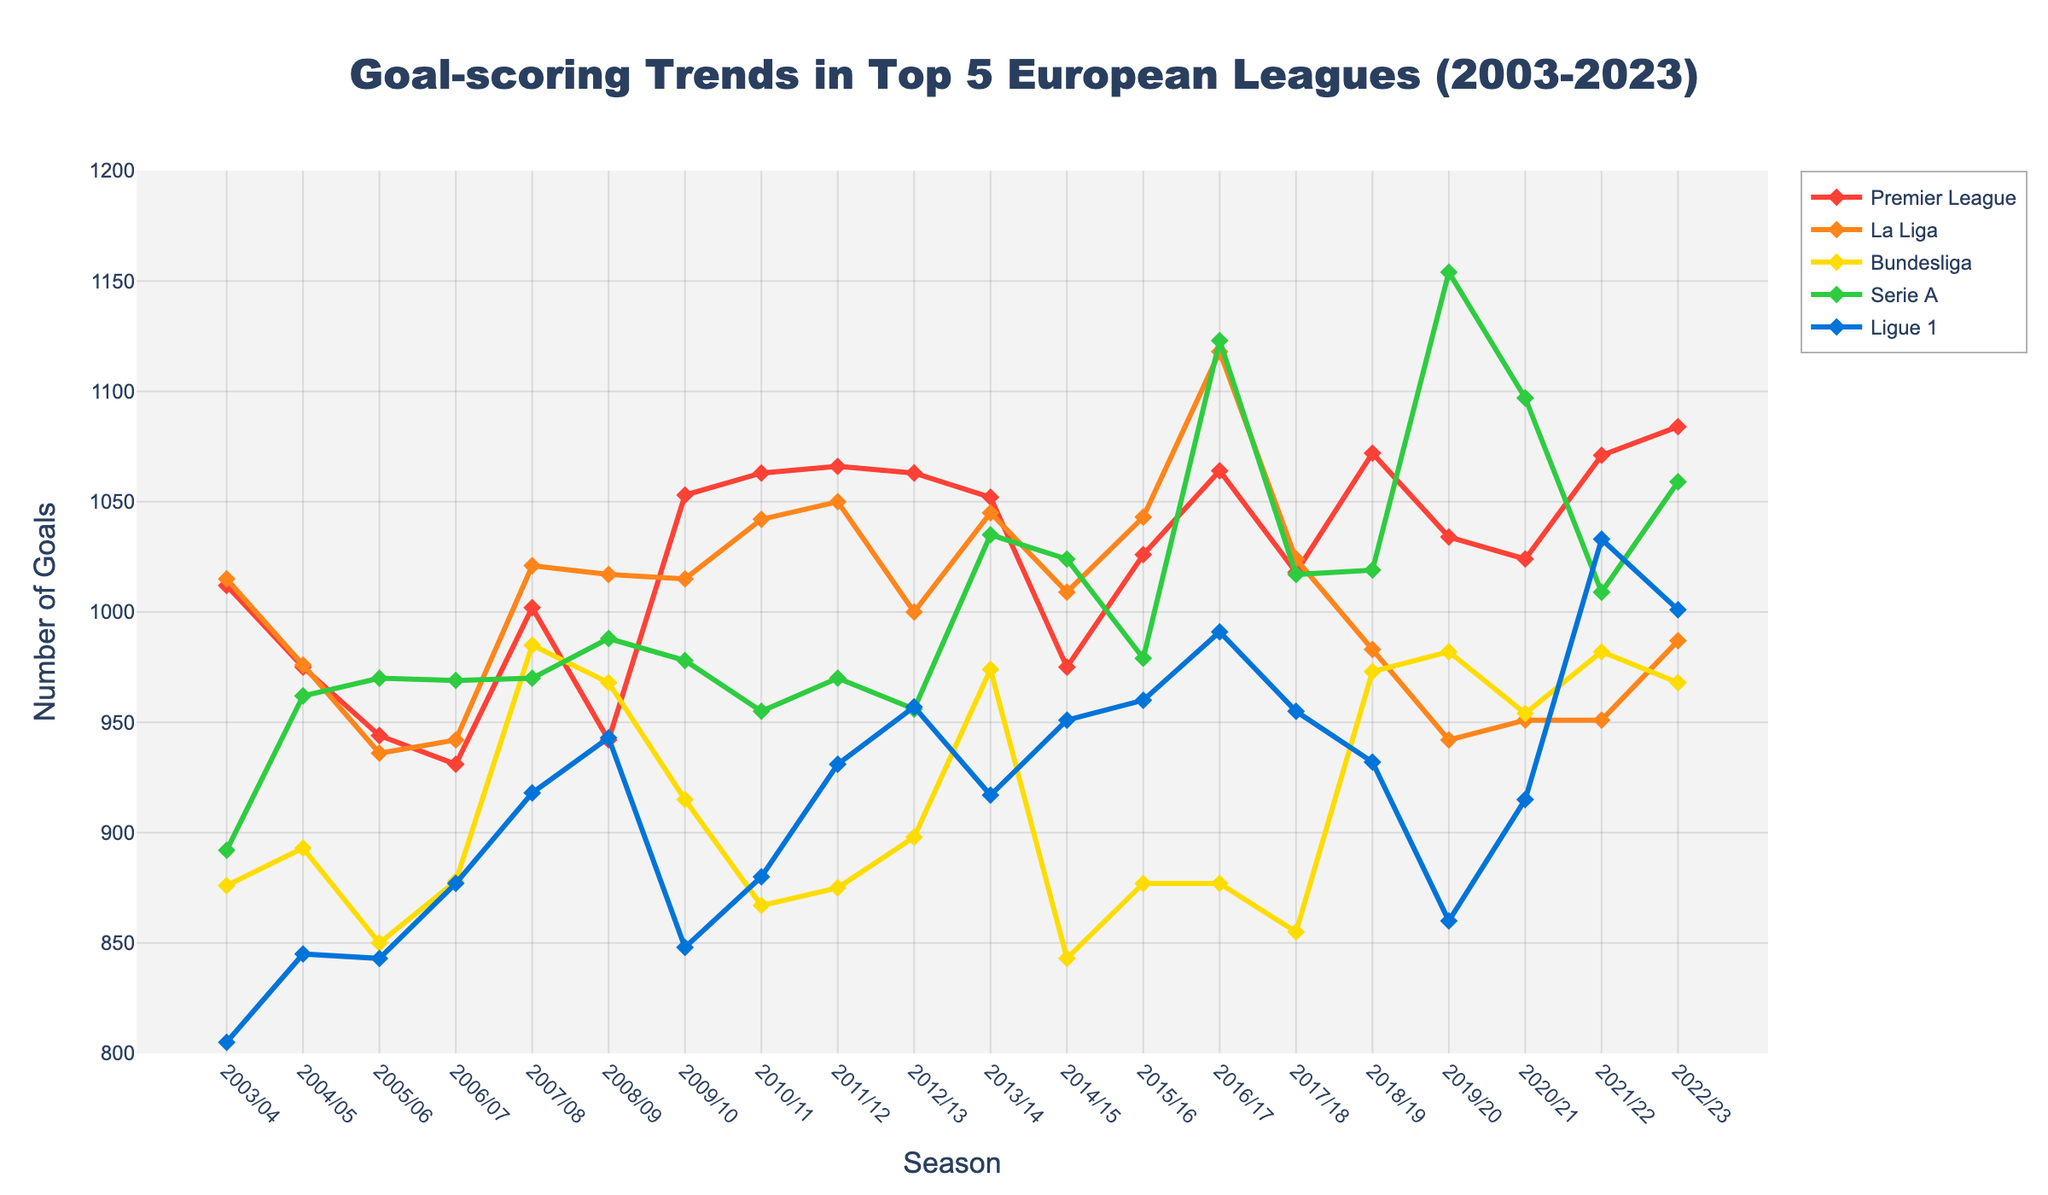Which league scored the most goals in the 2016/17 season? Looking at the 2016/17 season data, Serie A topped the chart with the highest number of goals scored.
Answer: Serie A In which season did the Bundesliga have its lowest goal tally? By examining the line for the Bundesliga, the lowest point occurs in the 2014/15 season.
Answer: 2014/15 Over the 20 seasons, did the Premier League ever score fewer goals than La Liga? By comparing the lines, we see that in the seasons 2004/05 and 2006/07, the Premier League scored fewer goals than La Liga.
Answer: Yes What's the average number of goals scored by Ligue 1 during the seasons 2003/04 to 2022/23? Sum up all the goals scored by Ligue 1 over the seasons and divide by the number of seasons (20). (805+845+843+877+918+943+848+880+931+957+917+951+960+991+955+932+860+915+1033+1001)/20 = 927.45
Answer: 927.45 Which league experienced the largest increase in goals scored from one season to the next, and in which seasons did this occur? Reviewing the line charts, the largest single-season increase for Serie A occurred from the 2015/16 to 2016/17 seasons (979 to 1123 goals), an increase of 144 goals.
Answer: Serie A, 2015/16 to 2016/17 How many seasons did Serie A surpass 1000 goals? Check the data for how many seasons Serie A crossed the 1000-goal mark, which are: 2013/14, 2014/15, 2016/17, 2017/18, 2018/19, 2019/20, 2020/21, 2021/22, 2022/23
Answer: 9 Comparing the Premier League in 2003/04 to its performance in 2022/23, did the number of goals increase or decrease? Comparing the values, the Premier League had 1012 goals in 2003/04 and increased to 1084 goals in 2022/23.
Answer: Increase Which league has the most consistent goal-scoring trend, showing the least variation over 20 seasons? Considering the smoothness and stability of the lines, Ligue 1 displays the most consistent trend with smaller fluctuations compared to other leagues.
Answer: Ligue 1 What is the total number of goals scored by La Liga during the first 10 seasons covered in the chart? Sum up La Liga's goals from 2003/04 to 2012/13: 1015+976+936+942+1021+1017+1015+1042+1050+1000 = 10014
Answer: 10014 Which league saw the highest number of goals scored in a single season and what was the count? The data shows that Serie A had the highest number of goals in a single season with 1154 goals in the 2019/20 season.
Answer: Serie A, 1154 